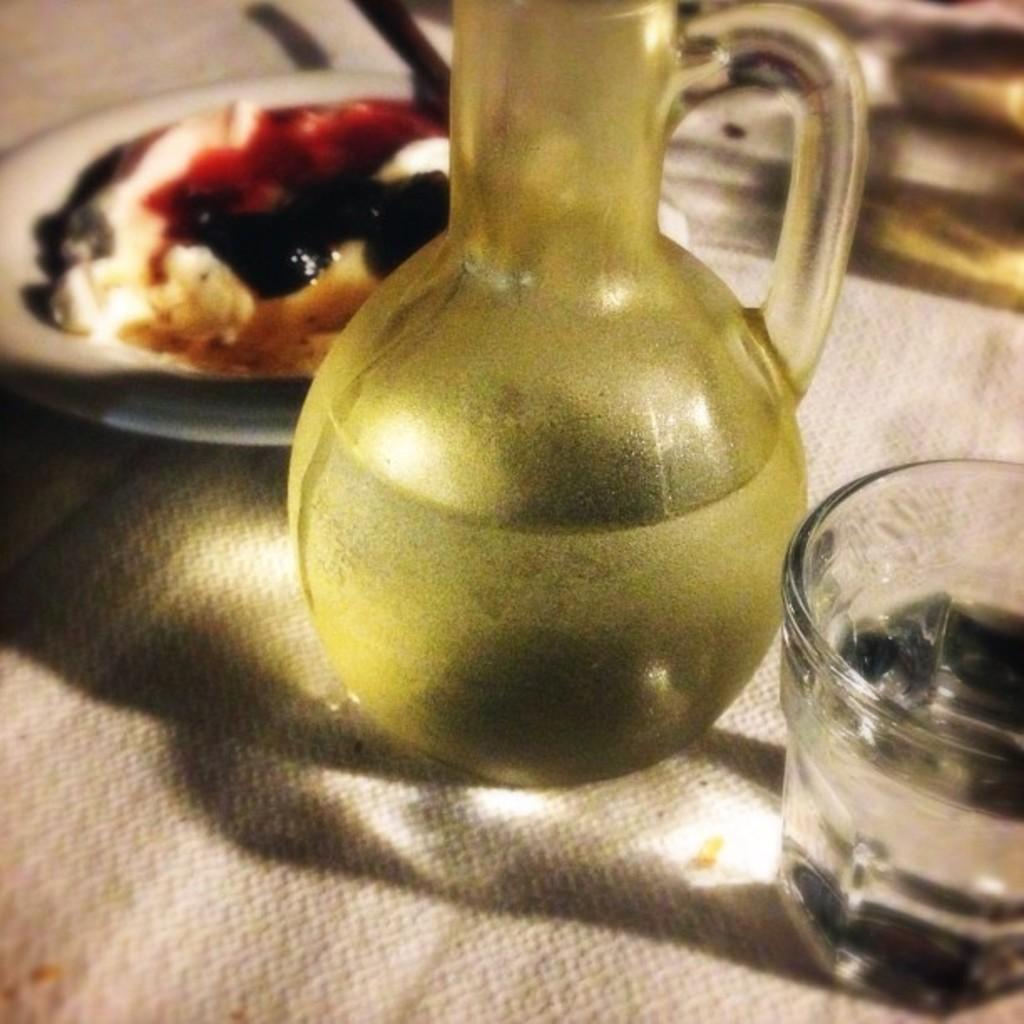Can you describe this image briefly? In the image we can see there is a jug of water and glass of water kept on the table. Behind there is a food item kept in the plate. 